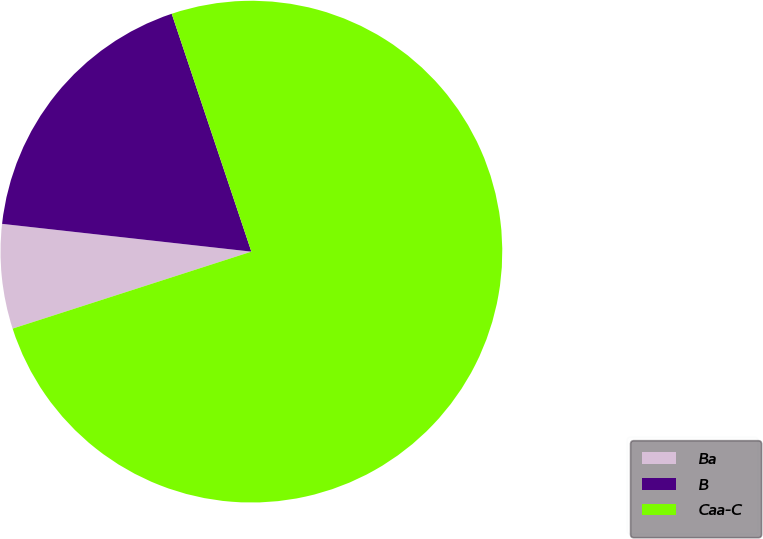<chart> <loc_0><loc_0><loc_500><loc_500><pie_chart><fcel>Ba<fcel>B<fcel>Caa-C<nl><fcel>6.73%<fcel>18.09%<fcel>75.18%<nl></chart> 